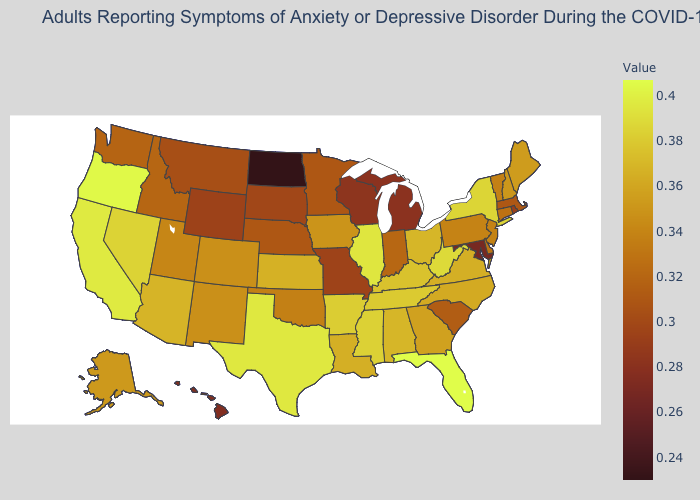Does Indiana have the highest value in the MidWest?
Answer briefly. No. Among the states that border West Virginia , does Kentucky have the highest value?
Write a very short answer. Yes. Among the states that border South Dakota , does North Dakota have the lowest value?
Quick response, please. Yes. Does the map have missing data?
Write a very short answer. No. Which states hav the highest value in the South?
Answer briefly. Florida. 